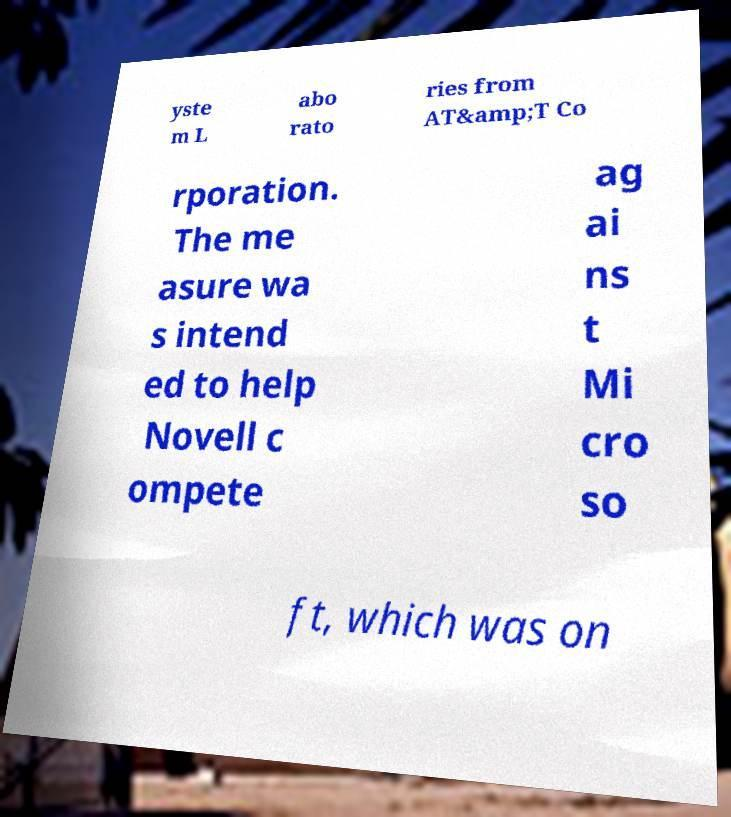Can you read and provide the text displayed in the image?This photo seems to have some interesting text. Can you extract and type it out for me? yste m L abo rato ries from AT&amp;T Co rporation. The me asure wa s intend ed to help Novell c ompete ag ai ns t Mi cro so ft, which was on 